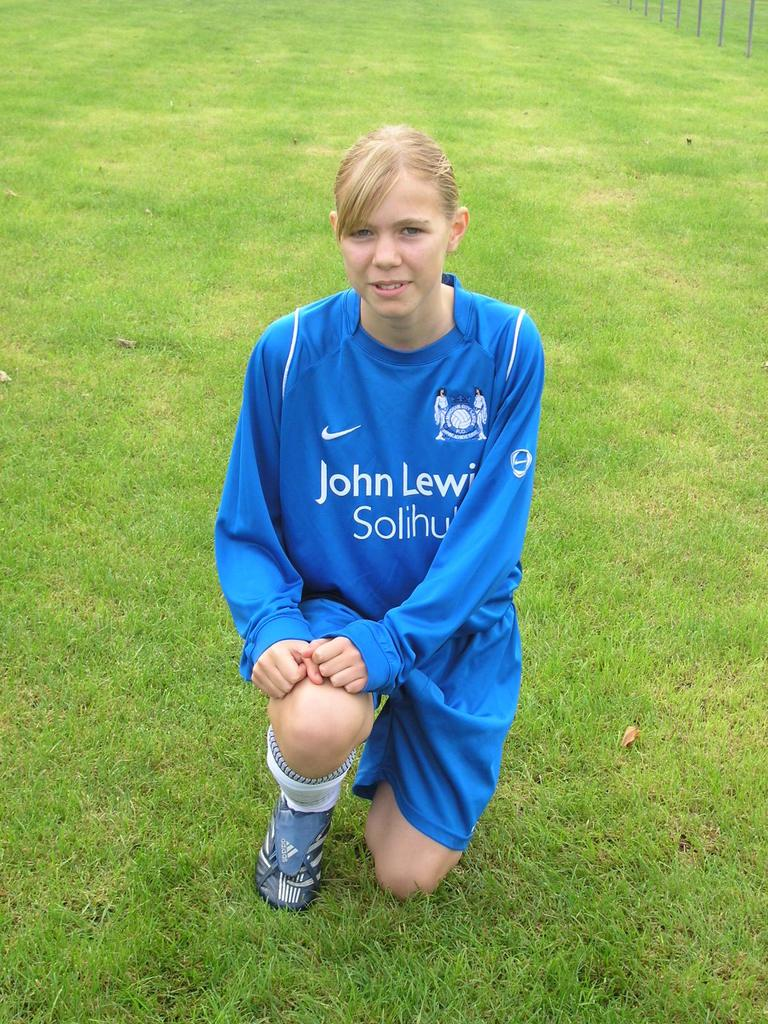Who is the main subject in the image? There is a woman in the image. What is the woman doing in the image? The woman is in a kneeling position on the grass. What can be seen in the background of the image? There are poles in the background of the image. What letters can be seen on the playground equipment in the image? There is no playground equipment or letters present in the image. What type of nose does the woman have in the image? The image does not provide enough detail to determine the woman's nose type. 